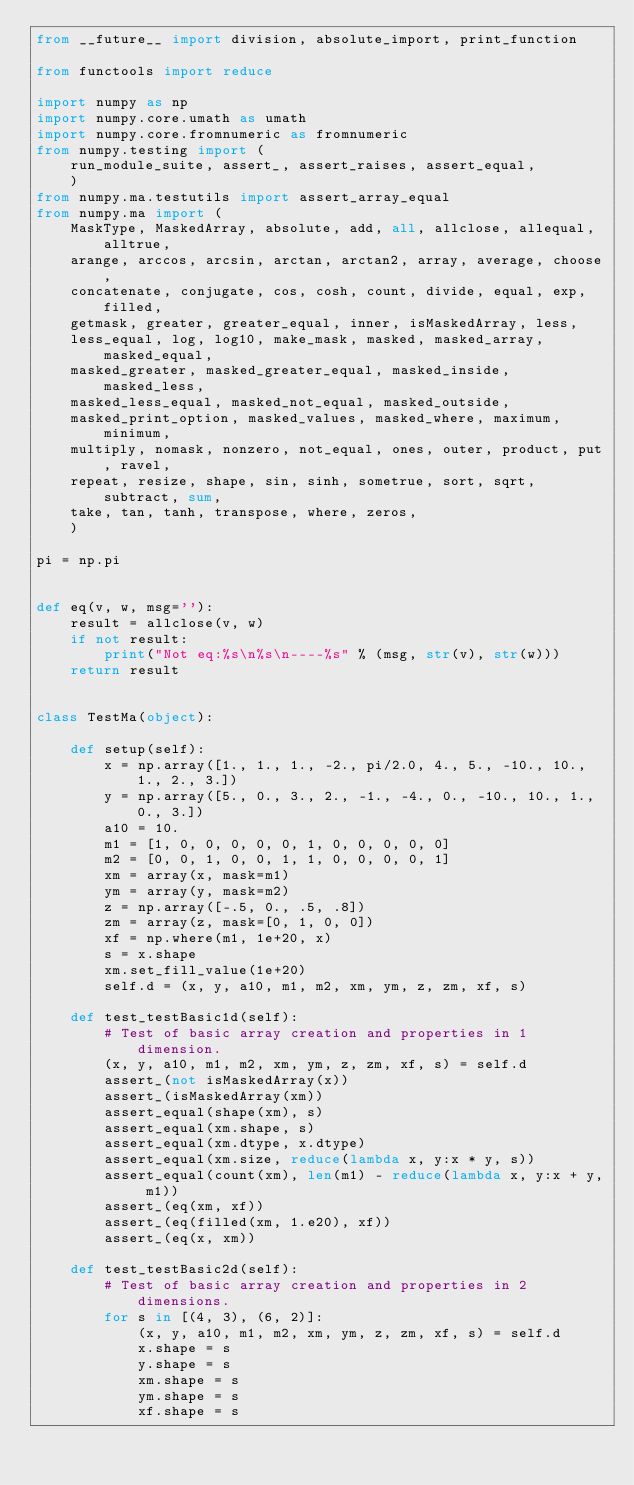Convert code to text. <code><loc_0><loc_0><loc_500><loc_500><_Python_>from __future__ import division, absolute_import, print_function

from functools import reduce

import numpy as np
import numpy.core.umath as umath
import numpy.core.fromnumeric as fromnumeric
from numpy.testing import (
    run_module_suite, assert_, assert_raises, assert_equal,
    )
from numpy.ma.testutils import assert_array_equal
from numpy.ma import (
    MaskType, MaskedArray, absolute, add, all, allclose, allequal, alltrue,
    arange, arccos, arcsin, arctan, arctan2, array, average, choose,
    concatenate, conjugate, cos, cosh, count, divide, equal, exp, filled,
    getmask, greater, greater_equal, inner, isMaskedArray, less,
    less_equal, log, log10, make_mask, masked, masked_array, masked_equal,
    masked_greater, masked_greater_equal, masked_inside, masked_less,
    masked_less_equal, masked_not_equal, masked_outside,
    masked_print_option, masked_values, masked_where, maximum, minimum,
    multiply, nomask, nonzero, not_equal, ones, outer, product, put, ravel,
    repeat, resize, shape, sin, sinh, sometrue, sort, sqrt, subtract, sum,
    take, tan, tanh, transpose, where, zeros,
    )

pi = np.pi


def eq(v, w, msg=''):
    result = allclose(v, w)
    if not result:
        print("Not eq:%s\n%s\n----%s" % (msg, str(v), str(w)))
    return result


class TestMa(object):

    def setup(self):
        x = np.array([1., 1., 1., -2., pi/2.0, 4., 5., -10., 10., 1., 2., 3.])
        y = np.array([5., 0., 3., 2., -1., -4., 0., -10., 10., 1., 0., 3.])
        a10 = 10.
        m1 = [1, 0, 0, 0, 0, 0, 1, 0, 0, 0, 0, 0]
        m2 = [0, 0, 1, 0, 0, 1, 1, 0, 0, 0, 0, 1]
        xm = array(x, mask=m1)
        ym = array(y, mask=m2)
        z = np.array([-.5, 0., .5, .8])
        zm = array(z, mask=[0, 1, 0, 0])
        xf = np.where(m1, 1e+20, x)
        s = x.shape
        xm.set_fill_value(1e+20)
        self.d = (x, y, a10, m1, m2, xm, ym, z, zm, xf, s)

    def test_testBasic1d(self):
        # Test of basic array creation and properties in 1 dimension.
        (x, y, a10, m1, m2, xm, ym, z, zm, xf, s) = self.d
        assert_(not isMaskedArray(x))
        assert_(isMaskedArray(xm))
        assert_equal(shape(xm), s)
        assert_equal(xm.shape, s)
        assert_equal(xm.dtype, x.dtype)
        assert_equal(xm.size, reduce(lambda x, y:x * y, s))
        assert_equal(count(xm), len(m1) - reduce(lambda x, y:x + y, m1))
        assert_(eq(xm, xf))
        assert_(eq(filled(xm, 1.e20), xf))
        assert_(eq(x, xm))

    def test_testBasic2d(self):
        # Test of basic array creation and properties in 2 dimensions.
        for s in [(4, 3), (6, 2)]:
            (x, y, a10, m1, m2, xm, ym, z, zm, xf, s) = self.d
            x.shape = s
            y.shape = s
            xm.shape = s
            ym.shape = s
            xf.shape = s
</code> 